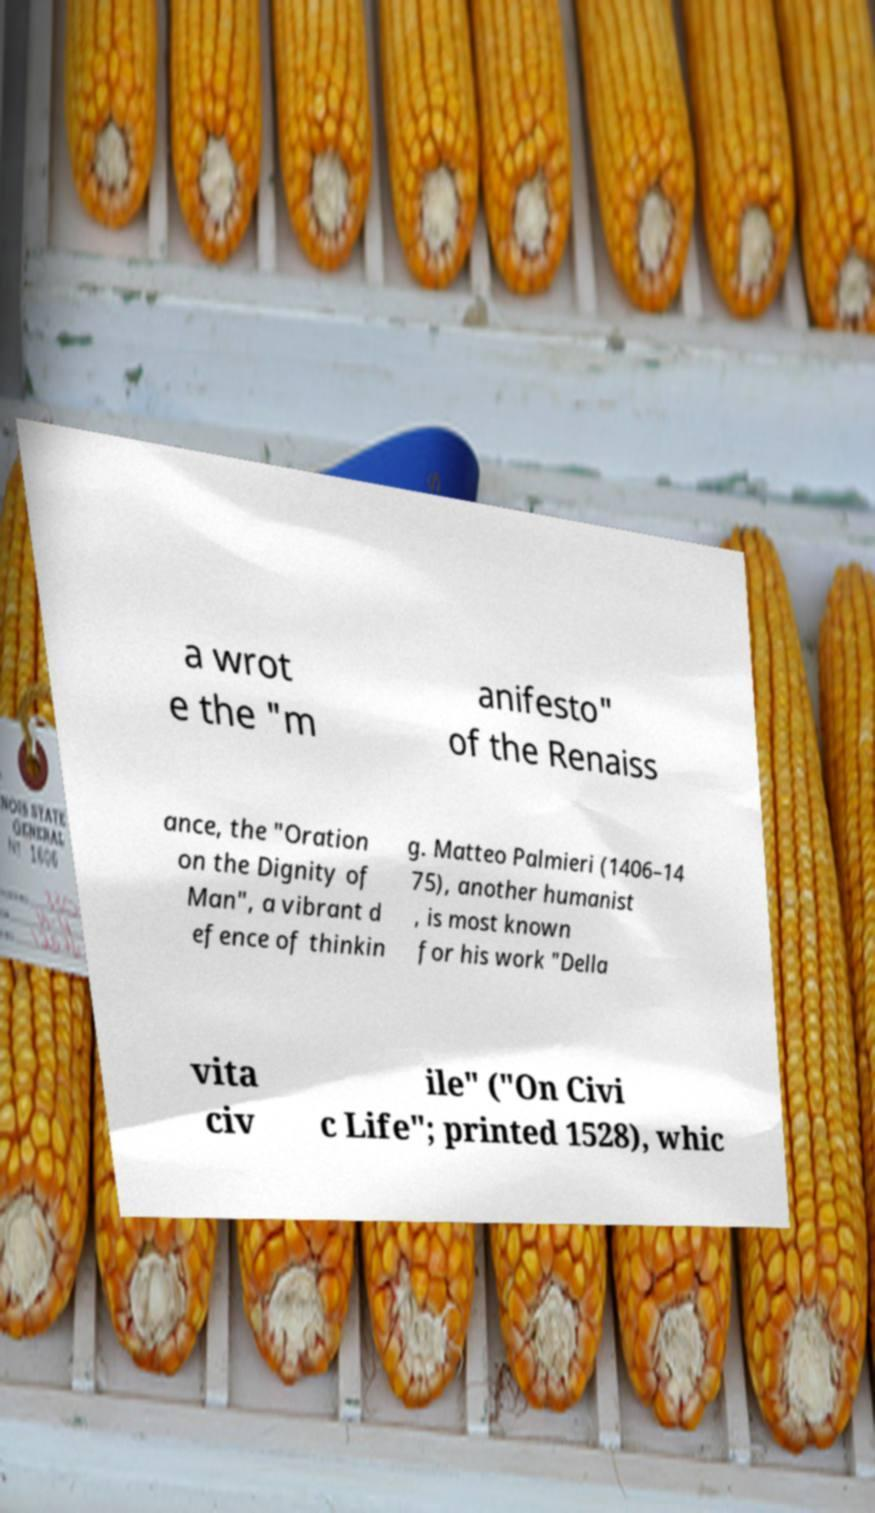Could you extract and type out the text from this image? a wrot e the "m anifesto" of the Renaiss ance, the "Oration on the Dignity of Man", a vibrant d efence of thinkin g. Matteo Palmieri (1406–14 75), another humanist , is most known for his work "Della vita civ ile" ("On Civi c Life"; printed 1528), whic 